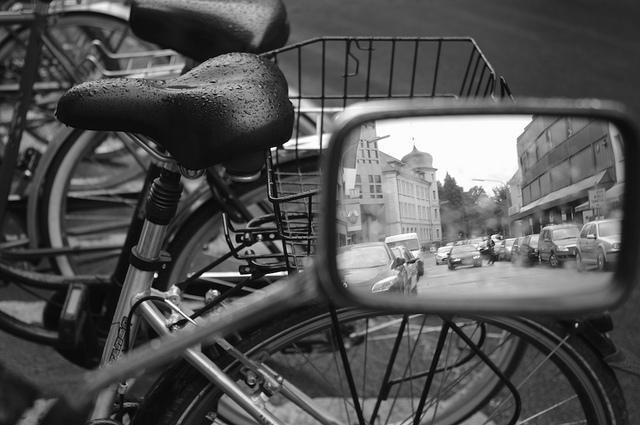Why is the black bike seat wet?
Choose the right answer from the provided options to respond to the question.
Options: Perspiration, sea mist, spill, rain. Rain. 